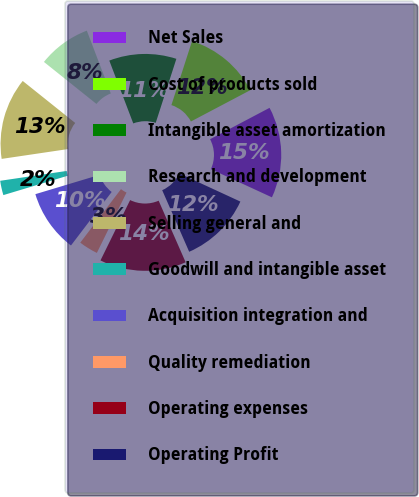<chart> <loc_0><loc_0><loc_500><loc_500><pie_chart><fcel>Net Sales<fcel>Cost of products sold<fcel>Intangible asset amortization<fcel>Research and development<fcel>Selling general and<fcel>Goodwill and intangible asset<fcel>Acquisition integration and<fcel>Quality remediation<fcel>Operating expenses<fcel>Operating Profit<nl><fcel>14.61%<fcel>12.31%<fcel>10.77%<fcel>8.46%<fcel>13.08%<fcel>2.31%<fcel>10.0%<fcel>3.08%<fcel>13.85%<fcel>11.54%<nl></chart> 